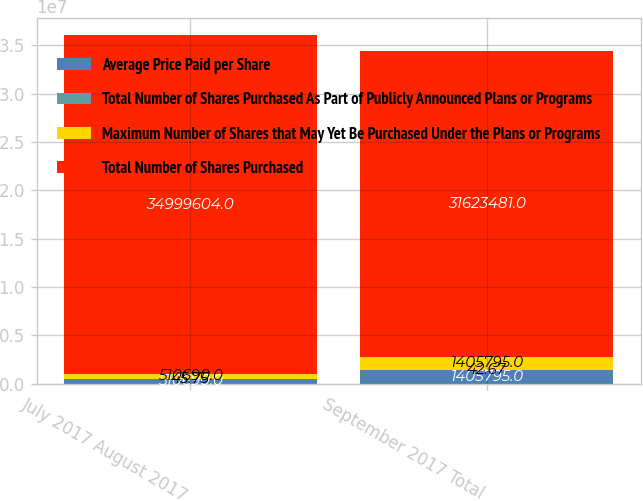Convert chart. <chart><loc_0><loc_0><loc_500><loc_500><stacked_bar_chart><ecel><fcel>July 2017 August 2017<fcel>September 2017 Total<nl><fcel>Average Price Paid per Share<fcel>510690<fcel>1.4058e+06<nl><fcel>Total Number of Shares Purchased As Part of Publicly Announced Plans or Programs<fcel>45.75<fcel>42.67<nl><fcel>Maximum Number of Shares that May Yet Be Purchased Under the Plans or Programs<fcel>510690<fcel>1.4058e+06<nl><fcel>Total Number of Shares Purchased<fcel>3.49996e+07<fcel>3.16235e+07<nl></chart> 